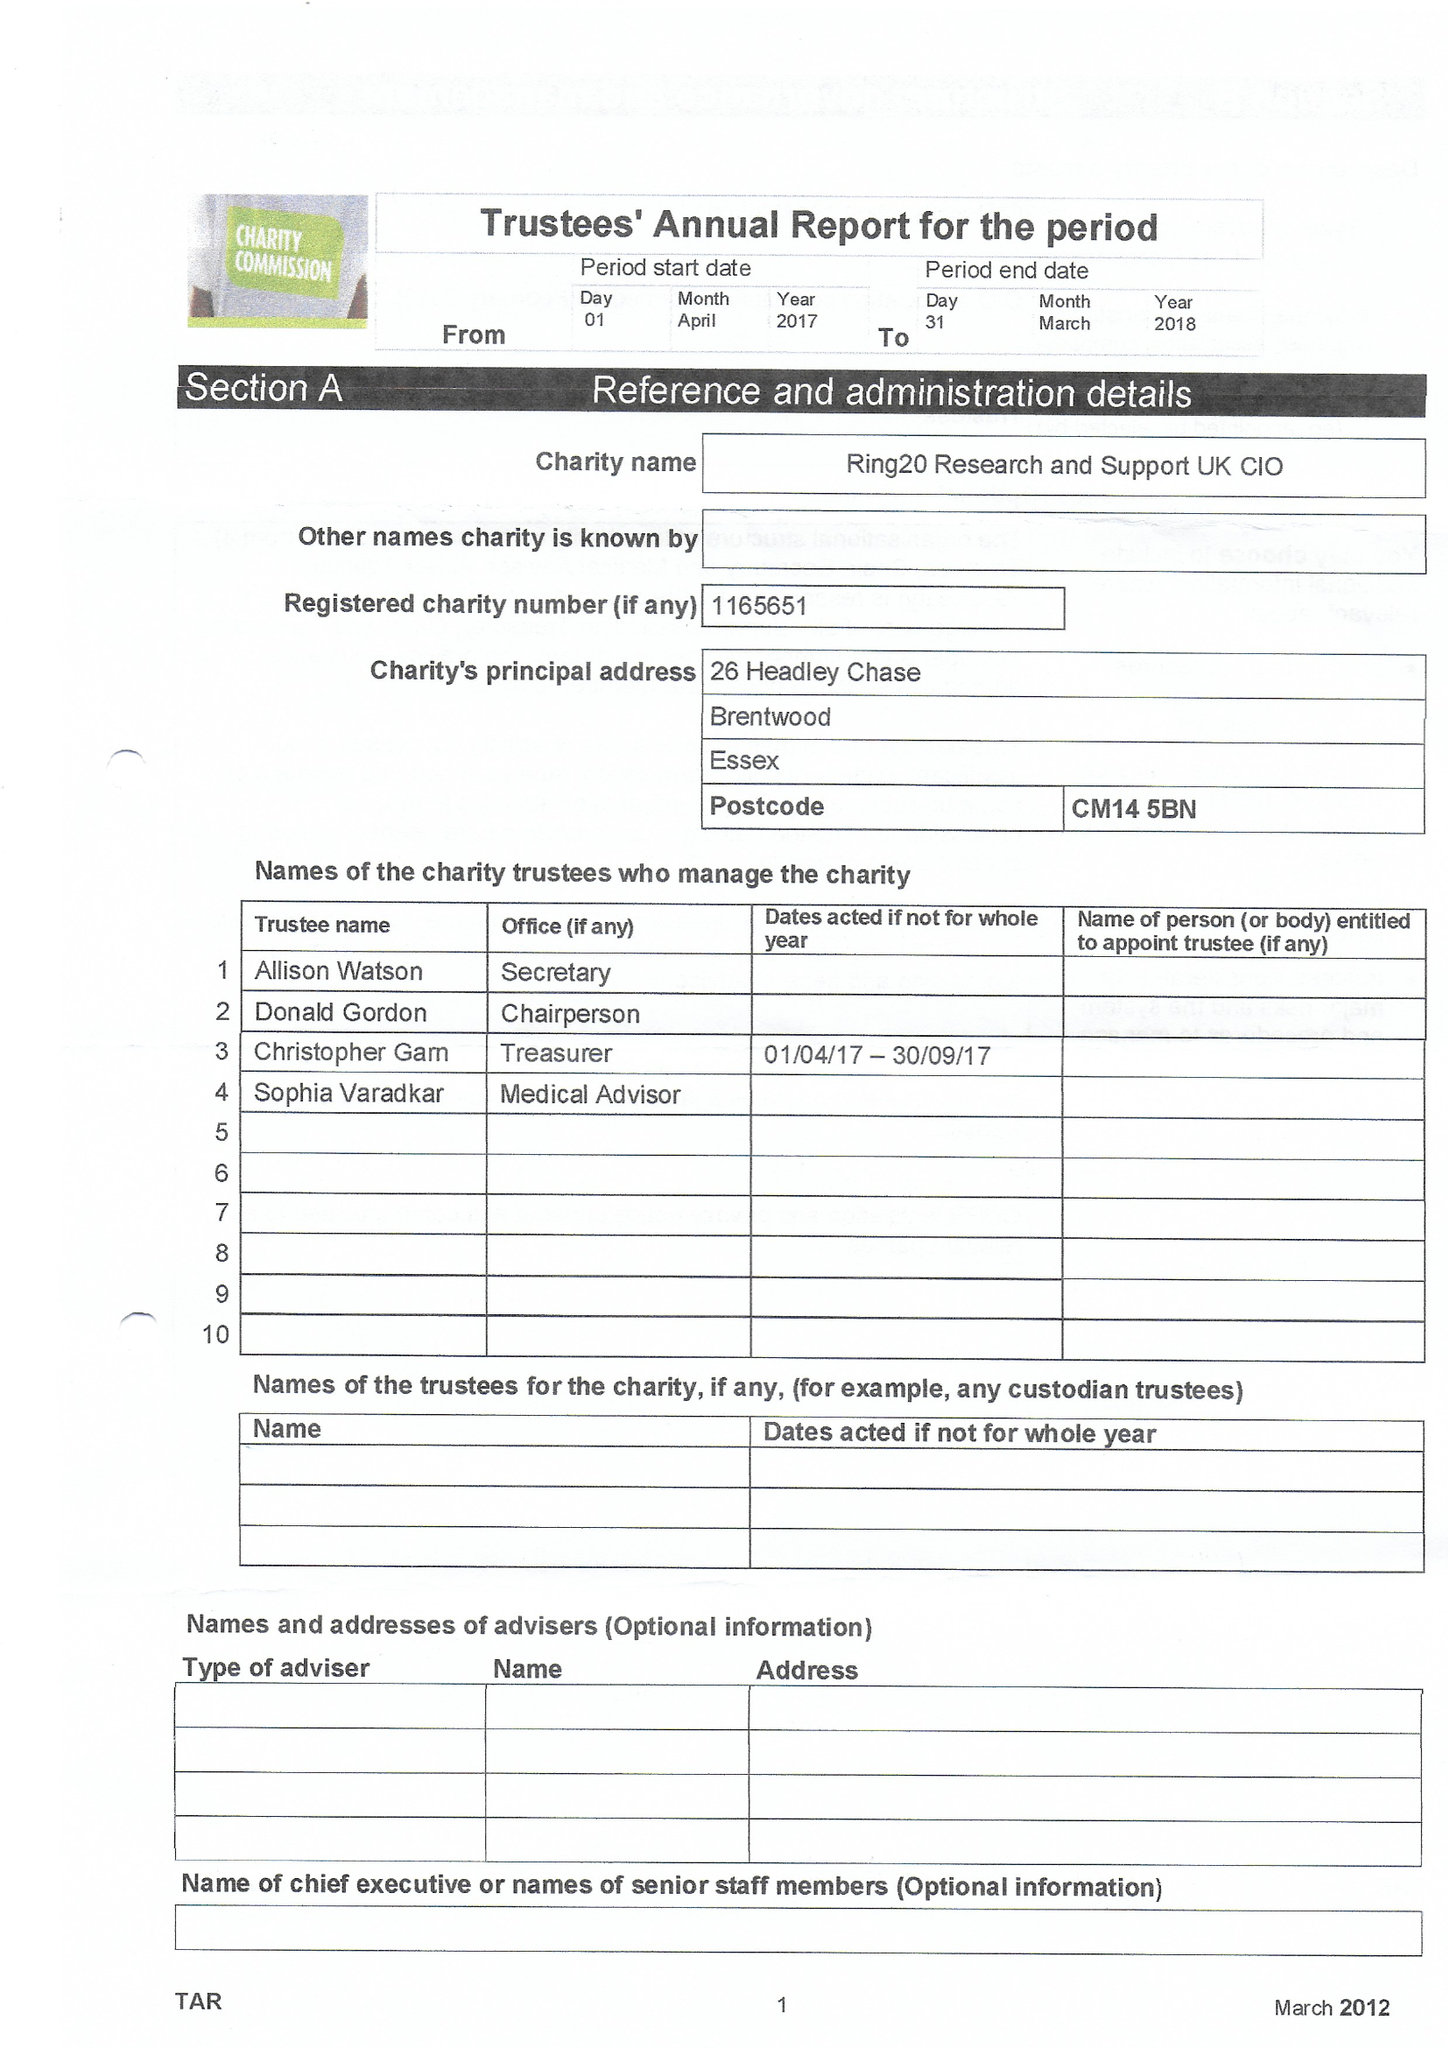What is the value for the address__postcode?
Answer the question using a single word or phrase. CM14 5BN 